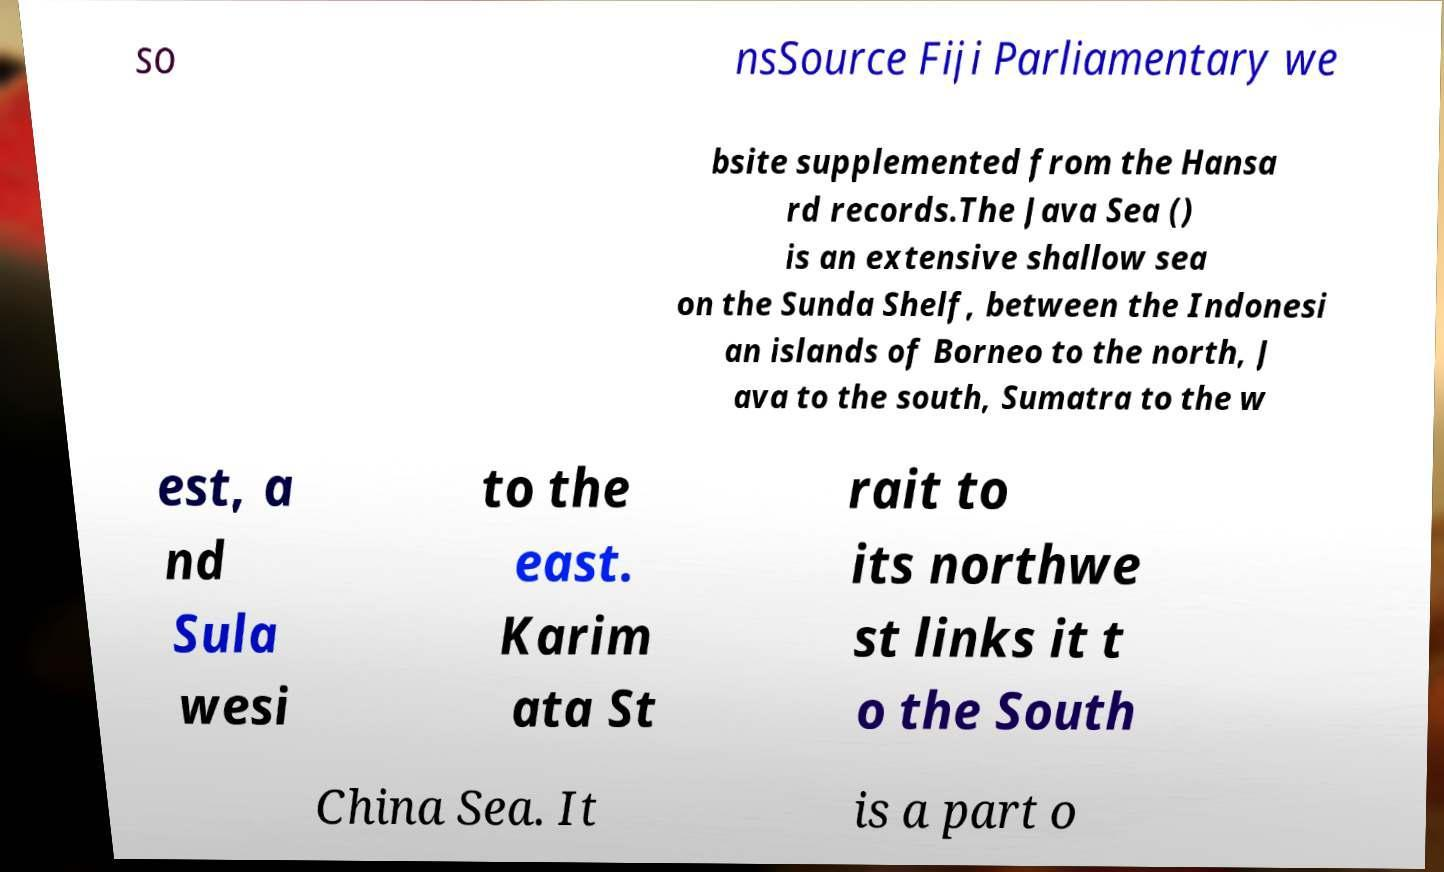Please read and relay the text visible in this image. What does it say? so nsSource Fiji Parliamentary we bsite supplemented from the Hansa rd records.The Java Sea () is an extensive shallow sea on the Sunda Shelf, between the Indonesi an islands of Borneo to the north, J ava to the south, Sumatra to the w est, a nd Sula wesi to the east. Karim ata St rait to its northwe st links it t o the South China Sea. It is a part o 